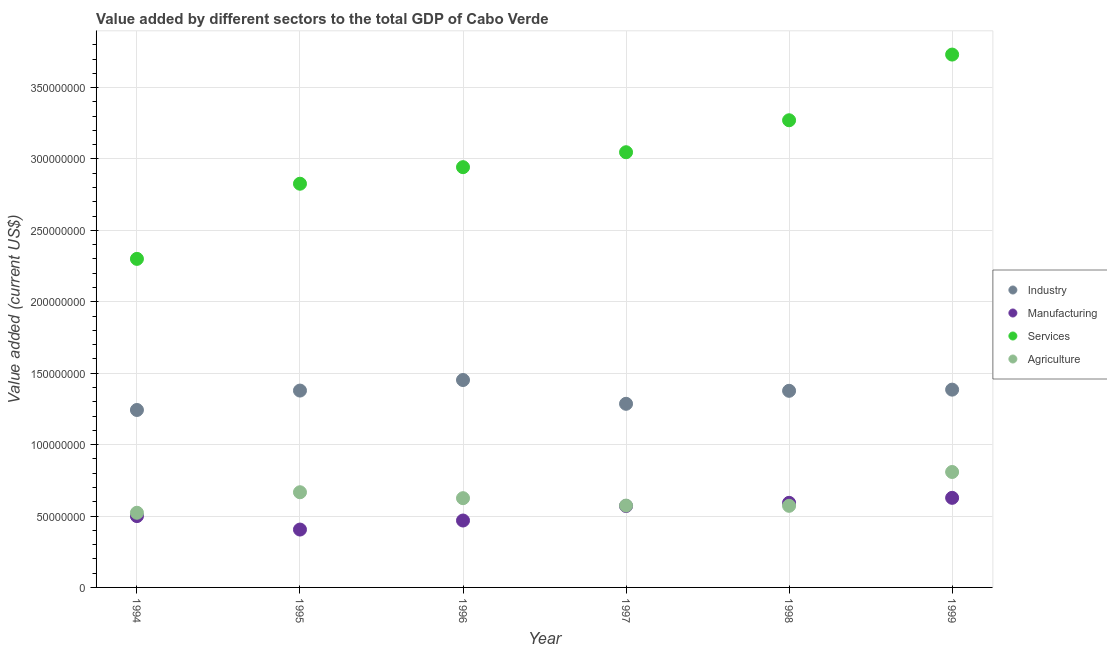Is the number of dotlines equal to the number of legend labels?
Keep it short and to the point. Yes. What is the value added by services sector in 1999?
Provide a succinct answer. 3.73e+08. Across all years, what is the maximum value added by manufacturing sector?
Your response must be concise. 6.27e+07. Across all years, what is the minimum value added by industrial sector?
Your answer should be compact. 1.24e+08. In which year was the value added by agricultural sector minimum?
Provide a short and direct response. 1994. What is the total value added by agricultural sector in the graph?
Your response must be concise. 3.77e+08. What is the difference between the value added by manufacturing sector in 1996 and that in 1998?
Your answer should be compact. -1.24e+07. What is the difference between the value added by industrial sector in 1998 and the value added by services sector in 1996?
Ensure brevity in your answer.  -1.57e+08. What is the average value added by industrial sector per year?
Keep it short and to the point. 1.35e+08. In the year 1998, what is the difference between the value added by services sector and value added by industrial sector?
Offer a terse response. 1.89e+08. What is the ratio of the value added by industrial sector in 1997 to that in 1998?
Your response must be concise. 0.93. Is the value added by agricultural sector in 1997 less than that in 1998?
Your answer should be very brief. No. What is the difference between the highest and the second highest value added by agricultural sector?
Offer a very short reply. 1.42e+07. What is the difference between the highest and the lowest value added by industrial sector?
Offer a terse response. 2.10e+07. In how many years, is the value added by manufacturing sector greater than the average value added by manufacturing sector taken over all years?
Provide a short and direct response. 3. Is the sum of the value added by agricultural sector in 1996 and 1997 greater than the maximum value added by industrial sector across all years?
Make the answer very short. No. Is it the case that in every year, the sum of the value added by industrial sector and value added by manufacturing sector is greater than the value added by services sector?
Keep it short and to the point. No. Does the value added by services sector monotonically increase over the years?
Make the answer very short. Yes. Is the value added by manufacturing sector strictly less than the value added by industrial sector over the years?
Your answer should be very brief. Yes. What is the difference between two consecutive major ticks on the Y-axis?
Offer a terse response. 5.00e+07. Does the graph contain any zero values?
Keep it short and to the point. No. Does the graph contain grids?
Offer a very short reply. Yes. What is the title of the graph?
Provide a short and direct response. Value added by different sectors to the total GDP of Cabo Verde. What is the label or title of the Y-axis?
Make the answer very short. Value added (current US$). What is the Value added (current US$) of Industry in 1994?
Your answer should be very brief. 1.24e+08. What is the Value added (current US$) in Manufacturing in 1994?
Ensure brevity in your answer.  4.99e+07. What is the Value added (current US$) in Services in 1994?
Your response must be concise. 2.30e+08. What is the Value added (current US$) of Agriculture in 1994?
Give a very brief answer. 5.23e+07. What is the Value added (current US$) of Industry in 1995?
Your response must be concise. 1.38e+08. What is the Value added (current US$) in Manufacturing in 1995?
Provide a short and direct response. 4.05e+07. What is the Value added (current US$) in Services in 1995?
Your answer should be very brief. 2.83e+08. What is the Value added (current US$) in Agriculture in 1995?
Offer a terse response. 6.66e+07. What is the Value added (current US$) of Industry in 1996?
Your answer should be very brief. 1.45e+08. What is the Value added (current US$) of Manufacturing in 1996?
Offer a very short reply. 4.68e+07. What is the Value added (current US$) in Services in 1996?
Provide a succinct answer. 2.94e+08. What is the Value added (current US$) in Agriculture in 1996?
Keep it short and to the point. 6.25e+07. What is the Value added (current US$) of Industry in 1997?
Your response must be concise. 1.29e+08. What is the Value added (current US$) of Manufacturing in 1997?
Give a very brief answer. 5.70e+07. What is the Value added (current US$) of Services in 1997?
Keep it short and to the point. 3.05e+08. What is the Value added (current US$) in Agriculture in 1997?
Give a very brief answer. 5.73e+07. What is the Value added (current US$) in Industry in 1998?
Give a very brief answer. 1.38e+08. What is the Value added (current US$) of Manufacturing in 1998?
Give a very brief answer. 5.92e+07. What is the Value added (current US$) in Services in 1998?
Provide a short and direct response. 3.27e+08. What is the Value added (current US$) in Agriculture in 1998?
Your answer should be compact. 5.71e+07. What is the Value added (current US$) of Industry in 1999?
Your answer should be compact. 1.38e+08. What is the Value added (current US$) of Manufacturing in 1999?
Your answer should be very brief. 6.27e+07. What is the Value added (current US$) in Services in 1999?
Your answer should be compact. 3.73e+08. What is the Value added (current US$) in Agriculture in 1999?
Make the answer very short. 8.08e+07. Across all years, what is the maximum Value added (current US$) of Industry?
Make the answer very short. 1.45e+08. Across all years, what is the maximum Value added (current US$) of Manufacturing?
Your response must be concise. 6.27e+07. Across all years, what is the maximum Value added (current US$) in Services?
Give a very brief answer. 3.73e+08. Across all years, what is the maximum Value added (current US$) in Agriculture?
Your response must be concise. 8.08e+07. Across all years, what is the minimum Value added (current US$) in Industry?
Your answer should be very brief. 1.24e+08. Across all years, what is the minimum Value added (current US$) of Manufacturing?
Ensure brevity in your answer.  4.05e+07. Across all years, what is the minimum Value added (current US$) in Services?
Offer a very short reply. 2.30e+08. Across all years, what is the minimum Value added (current US$) in Agriculture?
Keep it short and to the point. 5.23e+07. What is the total Value added (current US$) of Industry in the graph?
Offer a terse response. 8.12e+08. What is the total Value added (current US$) in Manufacturing in the graph?
Give a very brief answer. 3.16e+08. What is the total Value added (current US$) of Services in the graph?
Your answer should be very brief. 1.81e+09. What is the total Value added (current US$) in Agriculture in the graph?
Offer a very short reply. 3.77e+08. What is the difference between the Value added (current US$) of Industry in 1994 and that in 1995?
Provide a short and direct response. -1.36e+07. What is the difference between the Value added (current US$) of Manufacturing in 1994 and that in 1995?
Provide a succinct answer. 9.43e+06. What is the difference between the Value added (current US$) of Services in 1994 and that in 1995?
Ensure brevity in your answer.  -5.26e+07. What is the difference between the Value added (current US$) in Agriculture in 1994 and that in 1995?
Offer a terse response. -1.44e+07. What is the difference between the Value added (current US$) in Industry in 1994 and that in 1996?
Provide a succinct answer. -2.10e+07. What is the difference between the Value added (current US$) in Manufacturing in 1994 and that in 1996?
Your response must be concise. 3.10e+06. What is the difference between the Value added (current US$) of Services in 1994 and that in 1996?
Offer a very short reply. -6.42e+07. What is the difference between the Value added (current US$) in Agriculture in 1994 and that in 1996?
Keep it short and to the point. -1.02e+07. What is the difference between the Value added (current US$) of Industry in 1994 and that in 1997?
Keep it short and to the point. -4.33e+06. What is the difference between the Value added (current US$) of Manufacturing in 1994 and that in 1997?
Your answer should be compact. -7.07e+06. What is the difference between the Value added (current US$) of Services in 1994 and that in 1997?
Provide a succinct answer. -7.47e+07. What is the difference between the Value added (current US$) of Agriculture in 1994 and that in 1997?
Provide a short and direct response. -5.02e+06. What is the difference between the Value added (current US$) of Industry in 1994 and that in 1998?
Ensure brevity in your answer.  -1.34e+07. What is the difference between the Value added (current US$) of Manufacturing in 1994 and that in 1998?
Provide a succinct answer. -9.28e+06. What is the difference between the Value added (current US$) in Services in 1994 and that in 1998?
Keep it short and to the point. -9.71e+07. What is the difference between the Value added (current US$) in Agriculture in 1994 and that in 1998?
Give a very brief answer. -4.85e+06. What is the difference between the Value added (current US$) of Industry in 1994 and that in 1999?
Offer a terse response. -1.42e+07. What is the difference between the Value added (current US$) of Manufacturing in 1994 and that in 1999?
Provide a short and direct response. -1.28e+07. What is the difference between the Value added (current US$) in Services in 1994 and that in 1999?
Give a very brief answer. -1.43e+08. What is the difference between the Value added (current US$) of Agriculture in 1994 and that in 1999?
Provide a succinct answer. -2.85e+07. What is the difference between the Value added (current US$) in Industry in 1995 and that in 1996?
Offer a terse response. -7.39e+06. What is the difference between the Value added (current US$) of Manufacturing in 1995 and that in 1996?
Provide a succinct answer. -6.33e+06. What is the difference between the Value added (current US$) of Services in 1995 and that in 1996?
Your answer should be compact. -1.16e+07. What is the difference between the Value added (current US$) of Agriculture in 1995 and that in 1996?
Give a very brief answer. 4.16e+06. What is the difference between the Value added (current US$) of Industry in 1995 and that in 1997?
Provide a succinct answer. 9.26e+06. What is the difference between the Value added (current US$) in Manufacturing in 1995 and that in 1997?
Offer a terse response. -1.65e+07. What is the difference between the Value added (current US$) in Services in 1995 and that in 1997?
Keep it short and to the point. -2.21e+07. What is the difference between the Value added (current US$) of Agriculture in 1995 and that in 1997?
Keep it short and to the point. 9.34e+06. What is the difference between the Value added (current US$) of Industry in 1995 and that in 1998?
Offer a very short reply. 1.66e+05. What is the difference between the Value added (current US$) of Manufacturing in 1995 and that in 1998?
Provide a succinct answer. -1.87e+07. What is the difference between the Value added (current US$) in Services in 1995 and that in 1998?
Your answer should be very brief. -4.44e+07. What is the difference between the Value added (current US$) of Agriculture in 1995 and that in 1998?
Offer a very short reply. 9.51e+06. What is the difference between the Value added (current US$) of Industry in 1995 and that in 1999?
Keep it short and to the point. -6.55e+05. What is the difference between the Value added (current US$) of Manufacturing in 1995 and that in 1999?
Provide a succinct answer. -2.22e+07. What is the difference between the Value added (current US$) of Services in 1995 and that in 1999?
Your answer should be compact. -9.04e+07. What is the difference between the Value added (current US$) in Agriculture in 1995 and that in 1999?
Your response must be concise. -1.42e+07. What is the difference between the Value added (current US$) of Industry in 1996 and that in 1997?
Make the answer very short. 1.67e+07. What is the difference between the Value added (current US$) in Manufacturing in 1996 and that in 1997?
Keep it short and to the point. -1.02e+07. What is the difference between the Value added (current US$) in Services in 1996 and that in 1997?
Make the answer very short. -1.05e+07. What is the difference between the Value added (current US$) of Agriculture in 1996 and that in 1997?
Provide a short and direct response. 5.18e+06. What is the difference between the Value added (current US$) in Industry in 1996 and that in 1998?
Ensure brevity in your answer.  7.56e+06. What is the difference between the Value added (current US$) of Manufacturing in 1996 and that in 1998?
Ensure brevity in your answer.  -1.24e+07. What is the difference between the Value added (current US$) of Services in 1996 and that in 1998?
Offer a terse response. -3.28e+07. What is the difference between the Value added (current US$) of Agriculture in 1996 and that in 1998?
Offer a terse response. 5.35e+06. What is the difference between the Value added (current US$) in Industry in 1996 and that in 1999?
Your response must be concise. 6.74e+06. What is the difference between the Value added (current US$) in Manufacturing in 1996 and that in 1999?
Your answer should be very brief. -1.59e+07. What is the difference between the Value added (current US$) of Services in 1996 and that in 1999?
Your answer should be compact. -7.88e+07. What is the difference between the Value added (current US$) in Agriculture in 1996 and that in 1999?
Offer a very short reply. -1.83e+07. What is the difference between the Value added (current US$) of Industry in 1997 and that in 1998?
Offer a very short reply. -9.09e+06. What is the difference between the Value added (current US$) in Manufacturing in 1997 and that in 1998?
Give a very brief answer. -2.22e+06. What is the difference between the Value added (current US$) in Services in 1997 and that in 1998?
Ensure brevity in your answer.  -2.24e+07. What is the difference between the Value added (current US$) of Agriculture in 1997 and that in 1998?
Your answer should be very brief. 1.71e+05. What is the difference between the Value added (current US$) in Industry in 1997 and that in 1999?
Your answer should be very brief. -9.91e+06. What is the difference between the Value added (current US$) of Manufacturing in 1997 and that in 1999?
Keep it short and to the point. -5.71e+06. What is the difference between the Value added (current US$) in Services in 1997 and that in 1999?
Make the answer very short. -6.84e+07. What is the difference between the Value added (current US$) of Agriculture in 1997 and that in 1999?
Your answer should be very brief. -2.35e+07. What is the difference between the Value added (current US$) of Industry in 1998 and that in 1999?
Provide a succinct answer. -8.20e+05. What is the difference between the Value added (current US$) in Manufacturing in 1998 and that in 1999?
Offer a very short reply. -3.49e+06. What is the difference between the Value added (current US$) of Services in 1998 and that in 1999?
Provide a succinct answer. -4.60e+07. What is the difference between the Value added (current US$) in Agriculture in 1998 and that in 1999?
Make the answer very short. -2.37e+07. What is the difference between the Value added (current US$) of Industry in 1994 and the Value added (current US$) of Manufacturing in 1995?
Make the answer very short. 8.37e+07. What is the difference between the Value added (current US$) of Industry in 1994 and the Value added (current US$) of Services in 1995?
Ensure brevity in your answer.  -1.58e+08. What is the difference between the Value added (current US$) of Industry in 1994 and the Value added (current US$) of Agriculture in 1995?
Ensure brevity in your answer.  5.76e+07. What is the difference between the Value added (current US$) in Manufacturing in 1994 and the Value added (current US$) in Services in 1995?
Your answer should be very brief. -2.33e+08. What is the difference between the Value added (current US$) of Manufacturing in 1994 and the Value added (current US$) of Agriculture in 1995?
Make the answer very short. -1.67e+07. What is the difference between the Value added (current US$) of Services in 1994 and the Value added (current US$) of Agriculture in 1995?
Ensure brevity in your answer.  1.63e+08. What is the difference between the Value added (current US$) in Industry in 1994 and the Value added (current US$) in Manufacturing in 1996?
Your answer should be very brief. 7.74e+07. What is the difference between the Value added (current US$) in Industry in 1994 and the Value added (current US$) in Services in 1996?
Make the answer very short. -1.70e+08. What is the difference between the Value added (current US$) of Industry in 1994 and the Value added (current US$) of Agriculture in 1996?
Provide a short and direct response. 6.18e+07. What is the difference between the Value added (current US$) in Manufacturing in 1994 and the Value added (current US$) in Services in 1996?
Provide a short and direct response. -2.44e+08. What is the difference between the Value added (current US$) of Manufacturing in 1994 and the Value added (current US$) of Agriculture in 1996?
Your answer should be compact. -1.25e+07. What is the difference between the Value added (current US$) of Services in 1994 and the Value added (current US$) of Agriculture in 1996?
Offer a very short reply. 1.68e+08. What is the difference between the Value added (current US$) of Industry in 1994 and the Value added (current US$) of Manufacturing in 1997?
Provide a short and direct response. 6.72e+07. What is the difference between the Value added (current US$) of Industry in 1994 and the Value added (current US$) of Services in 1997?
Ensure brevity in your answer.  -1.80e+08. What is the difference between the Value added (current US$) of Industry in 1994 and the Value added (current US$) of Agriculture in 1997?
Provide a succinct answer. 6.69e+07. What is the difference between the Value added (current US$) in Manufacturing in 1994 and the Value added (current US$) in Services in 1997?
Offer a very short reply. -2.55e+08. What is the difference between the Value added (current US$) in Manufacturing in 1994 and the Value added (current US$) in Agriculture in 1997?
Offer a terse response. -7.36e+06. What is the difference between the Value added (current US$) in Services in 1994 and the Value added (current US$) in Agriculture in 1997?
Provide a succinct answer. 1.73e+08. What is the difference between the Value added (current US$) of Industry in 1994 and the Value added (current US$) of Manufacturing in 1998?
Keep it short and to the point. 6.50e+07. What is the difference between the Value added (current US$) in Industry in 1994 and the Value added (current US$) in Services in 1998?
Ensure brevity in your answer.  -2.03e+08. What is the difference between the Value added (current US$) of Industry in 1994 and the Value added (current US$) of Agriculture in 1998?
Keep it short and to the point. 6.71e+07. What is the difference between the Value added (current US$) of Manufacturing in 1994 and the Value added (current US$) of Services in 1998?
Ensure brevity in your answer.  -2.77e+08. What is the difference between the Value added (current US$) of Manufacturing in 1994 and the Value added (current US$) of Agriculture in 1998?
Provide a succinct answer. -7.19e+06. What is the difference between the Value added (current US$) in Services in 1994 and the Value added (current US$) in Agriculture in 1998?
Offer a very short reply. 1.73e+08. What is the difference between the Value added (current US$) in Industry in 1994 and the Value added (current US$) in Manufacturing in 1999?
Offer a terse response. 6.15e+07. What is the difference between the Value added (current US$) in Industry in 1994 and the Value added (current US$) in Services in 1999?
Keep it short and to the point. -2.49e+08. What is the difference between the Value added (current US$) in Industry in 1994 and the Value added (current US$) in Agriculture in 1999?
Your answer should be very brief. 4.34e+07. What is the difference between the Value added (current US$) in Manufacturing in 1994 and the Value added (current US$) in Services in 1999?
Ensure brevity in your answer.  -3.23e+08. What is the difference between the Value added (current US$) in Manufacturing in 1994 and the Value added (current US$) in Agriculture in 1999?
Your answer should be compact. -3.09e+07. What is the difference between the Value added (current US$) in Services in 1994 and the Value added (current US$) in Agriculture in 1999?
Provide a succinct answer. 1.49e+08. What is the difference between the Value added (current US$) of Industry in 1995 and the Value added (current US$) of Manufacturing in 1996?
Offer a terse response. 9.10e+07. What is the difference between the Value added (current US$) in Industry in 1995 and the Value added (current US$) in Services in 1996?
Your answer should be compact. -1.56e+08. What is the difference between the Value added (current US$) in Industry in 1995 and the Value added (current US$) in Agriculture in 1996?
Your response must be concise. 7.53e+07. What is the difference between the Value added (current US$) of Manufacturing in 1995 and the Value added (current US$) of Services in 1996?
Offer a very short reply. -2.54e+08. What is the difference between the Value added (current US$) in Manufacturing in 1995 and the Value added (current US$) in Agriculture in 1996?
Offer a terse response. -2.20e+07. What is the difference between the Value added (current US$) in Services in 1995 and the Value added (current US$) in Agriculture in 1996?
Your response must be concise. 2.20e+08. What is the difference between the Value added (current US$) of Industry in 1995 and the Value added (current US$) of Manufacturing in 1997?
Your answer should be compact. 8.08e+07. What is the difference between the Value added (current US$) of Industry in 1995 and the Value added (current US$) of Services in 1997?
Give a very brief answer. -1.67e+08. What is the difference between the Value added (current US$) in Industry in 1995 and the Value added (current US$) in Agriculture in 1997?
Give a very brief answer. 8.05e+07. What is the difference between the Value added (current US$) in Manufacturing in 1995 and the Value added (current US$) in Services in 1997?
Offer a very short reply. -2.64e+08. What is the difference between the Value added (current US$) in Manufacturing in 1995 and the Value added (current US$) in Agriculture in 1997?
Provide a short and direct response. -1.68e+07. What is the difference between the Value added (current US$) in Services in 1995 and the Value added (current US$) in Agriculture in 1997?
Provide a succinct answer. 2.25e+08. What is the difference between the Value added (current US$) in Industry in 1995 and the Value added (current US$) in Manufacturing in 1998?
Offer a terse response. 7.86e+07. What is the difference between the Value added (current US$) in Industry in 1995 and the Value added (current US$) in Services in 1998?
Offer a very short reply. -1.89e+08. What is the difference between the Value added (current US$) in Industry in 1995 and the Value added (current US$) in Agriculture in 1998?
Ensure brevity in your answer.  8.07e+07. What is the difference between the Value added (current US$) of Manufacturing in 1995 and the Value added (current US$) of Services in 1998?
Make the answer very short. -2.87e+08. What is the difference between the Value added (current US$) of Manufacturing in 1995 and the Value added (current US$) of Agriculture in 1998?
Keep it short and to the point. -1.66e+07. What is the difference between the Value added (current US$) in Services in 1995 and the Value added (current US$) in Agriculture in 1998?
Your response must be concise. 2.26e+08. What is the difference between the Value added (current US$) of Industry in 1995 and the Value added (current US$) of Manufacturing in 1999?
Provide a succinct answer. 7.51e+07. What is the difference between the Value added (current US$) in Industry in 1995 and the Value added (current US$) in Services in 1999?
Provide a short and direct response. -2.35e+08. What is the difference between the Value added (current US$) in Industry in 1995 and the Value added (current US$) in Agriculture in 1999?
Make the answer very short. 5.70e+07. What is the difference between the Value added (current US$) in Manufacturing in 1995 and the Value added (current US$) in Services in 1999?
Provide a short and direct response. -3.33e+08. What is the difference between the Value added (current US$) of Manufacturing in 1995 and the Value added (current US$) of Agriculture in 1999?
Provide a succinct answer. -4.03e+07. What is the difference between the Value added (current US$) in Services in 1995 and the Value added (current US$) in Agriculture in 1999?
Provide a succinct answer. 2.02e+08. What is the difference between the Value added (current US$) in Industry in 1996 and the Value added (current US$) in Manufacturing in 1997?
Give a very brief answer. 8.82e+07. What is the difference between the Value added (current US$) of Industry in 1996 and the Value added (current US$) of Services in 1997?
Your answer should be very brief. -1.60e+08. What is the difference between the Value added (current US$) in Industry in 1996 and the Value added (current US$) in Agriculture in 1997?
Provide a short and direct response. 8.79e+07. What is the difference between the Value added (current US$) of Manufacturing in 1996 and the Value added (current US$) of Services in 1997?
Your answer should be compact. -2.58e+08. What is the difference between the Value added (current US$) of Manufacturing in 1996 and the Value added (current US$) of Agriculture in 1997?
Provide a succinct answer. -1.05e+07. What is the difference between the Value added (current US$) in Services in 1996 and the Value added (current US$) in Agriculture in 1997?
Your response must be concise. 2.37e+08. What is the difference between the Value added (current US$) of Industry in 1996 and the Value added (current US$) of Manufacturing in 1998?
Provide a short and direct response. 8.60e+07. What is the difference between the Value added (current US$) in Industry in 1996 and the Value added (current US$) in Services in 1998?
Make the answer very short. -1.82e+08. What is the difference between the Value added (current US$) of Industry in 1996 and the Value added (current US$) of Agriculture in 1998?
Give a very brief answer. 8.81e+07. What is the difference between the Value added (current US$) in Manufacturing in 1996 and the Value added (current US$) in Services in 1998?
Your response must be concise. -2.80e+08. What is the difference between the Value added (current US$) of Manufacturing in 1996 and the Value added (current US$) of Agriculture in 1998?
Keep it short and to the point. -1.03e+07. What is the difference between the Value added (current US$) of Services in 1996 and the Value added (current US$) of Agriculture in 1998?
Keep it short and to the point. 2.37e+08. What is the difference between the Value added (current US$) of Industry in 1996 and the Value added (current US$) of Manufacturing in 1999?
Offer a very short reply. 8.25e+07. What is the difference between the Value added (current US$) of Industry in 1996 and the Value added (current US$) of Services in 1999?
Your answer should be compact. -2.28e+08. What is the difference between the Value added (current US$) in Industry in 1996 and the Value added (current US$) in Agriculture in 1999?
Offer a very short reply. 6.44e+07. What is the difference between the Value added (current US$) of Manufacturing in 1996 and the Value added (current US$) of Services in 1999?
Your response must be concise. -3.26e+08. What is the difference between the Value added (current US$) in Manufacturing in 1996 and the Value added (current US$) in Agriculture in 1999?
Provide a succinct answer. -3.40e+07. What is the difference between the Value added (current US$) in Services in 1996 and the Value added (current US$) in Agriculture in 1999?
Offer a terse response. 2.13e+08. What is the difference between the Value added (current US$) in Industry in 1997 and the Value added (current US$) in Manufacturing in 1998?
Ensure brevity in your answer.  6.93e+07. What is the difference between the Value added (current US$) in Industry in 1997 and the Value added (current US$) in Services in 1998?
Make the answer very short. -1.99e+08. What is the difference between the Value added (current US$) in Industry in 1997 and the Value added (current US$) in Agriculture in 1998?
Your response must be concise. 7.14e+07. What is the difference between the Value added (current US$) of Manufacturing in 1997 and the Value added (current US$) of Services in 1998?
Provide a succinct answer. -2.70e+08. What is the difference between the Value added (current US$) of Manufacturing in 1997 and the Value added (current US$) of Agriculture in 1998?
Give a very brief answer. -1.19e+05. What is the difference between the Value added (current US$) of Services in 1997 and the Value added (current US$) of Agriculture in 1998?
Your answer should be compact. 2.48e+08. What is the difference between the Value added (current US$) of Industry in 1997 and the Value added (current US$) of Manufacturing in 1999?
Give a very brief answer. 6.58e+07. What is the difference between the Value added (current US$) of Industry in 1997 and the Value added (current US$) of Services in 1999?
Provide a succinct answer. -2.45e+08. What is the difference between the Value added (current US$) in Industry in 1997 and the Value added (current US$) in Agriculture in 1999?
Offer a very short reply. 4.77e+07. What is the difference between the Value added (current US$) of Manufacturing in 1997 and the Value added (current US$) of Services in 1999?
Your answer should be very brief. -3.16e+08. What is the difference between the Value added (current US$) of Manufacturing in 1997 and the Value added (current US$) of Agriculture in 1999?
Your response must be concise. -2.38e+07. What is the difference between the Value added (current US$) in Services in 1997 and the Value added (current US$) in Agriculture in 1999?
Make the answer very short. 2.24e+08. What is the difference between the Value added (current US$) in Industry in 1998 and the Value added (current US$) in Manufacturing in 1999?
Your response must be concise. 7.49e+07. What is the difference between the Value added (current US$) of Industry in 1998 and the Value added (current US$) of Services in 1999?
Offer a very short reply. -2.35e+08. What is the difference between the Value added (current US$) of Industry in 1998 and the Value added (current US$) of Agriculture in 1999?
Ensure brevity in your answer.  5.68e+07. What is the difference between the Value added (current US$) of Manufacturing in 1998 and the Value added (current US$) of Services in 1999?
Make the answer very short. -3.14e+08. What is the difference between the Value added (current US$) in Manufacturing in 1998 and the Value added (current US$) in Agriculture in 1999?
Ensure brevity in your answer.  -2.16e+07. What is the difference between the Value added (current US$) in Services in 1998 and the Value added (current US$) in Agriculture in 1999?
Provide a short and direct response. 2.46e+08. What is the average Value added (current US$) in Industry per year?
Your response must be concise. 1.35e+08. What is the average Value added (current US$) in Manufacturing per year?
Give a very brief answer. 5.27e+07. What is the average Value added (current US$) of Services per year?
Provide a succinct answer. 3.02e+08. What is the average Value added (current US$) of Agriculture per year?
Make the answer very short. 6.28e+07. In the year 1994, what is the difference between the Value added (current US$) in Industry and Value added (current US$) in Manufacturing?
Keep it short and to the point. 7.43e+07. In the year 1994, what is the difference between the Value added (current US$) in Industry and Value added (current US$) in Services?
Provide a short and direct response. -1.06e+08. In the year 1994, what is the difference between the Value added (current US$) in Industry and Value added (current US$) in Agriculture?
Ensure brevity in your answer.  7.20e+07. In the year 1994, what is the difference between the Value added (current US$) of Manufacturing and Value added (current US$) of Services?
Offer a terse response. -1.80e+08. In the year 1994, what is the difference between the Value added (current US$) of Manufacturing and Value added (current US$) of Agriculture?
Give a very brief answer. -2.33e+06. In the year 1994, what is the difference between the Value added (current US$) of Services and Value added (current US$) of Agriculture?
Provide a succinct answer. 1.78e+08. In the year 1995, what is the difference between the Value added (current US$) of Industry and Value added (current US$) of Manufacturing?
Make the answer very short. 9.73e+07. In the year 1995, what is the difference between the Value added (current US$) in Industry and Value added (current US$) in Services?
Provide a short and direct response. -1.45e+08. In the year 1995, what is the difference between the Value added (current US$) in Industry and Value added (current US$) in Agriculture?
Ensure brevity in your answer.  7.12e+07. In the year 1995, what is the difference between the Value added (current US$) of Manufacturing and Value added (current US$) of Services?
Ensure brevity in your answer.  -2.42e+08. In the year 1995, what is the difference between the Value added (current US$) of Manufacturing and Value added (current US$) of Agriculture?
Your answer should be very brief. -2.61e+07. In the year 1995, what is the difference between the Value added (current US$) in Services and Value added (current US$) in Agriculture?
Your answer should be compact. 2.16e+08. In the year 1996, what is the difference between the Value added (current US$) in Industry and Value added (current US$) in Manufacturing?
Keep it short and to the point. 9.84e+07. In the year 1996, what is the difference between the Value added (current US$) in Industry and Value added (current US$) in Services?
Ensure brevity in your answer.  -1.49e+08. In the year 1996, what is the difference between the Value added (current US$) in Industry and Value added (current US$) in Agriculture?
Your answer should be compact. 8.27e+07. In the year 1996, what is the difference between the Value added (current US$) of Manufacturing and Value added (current US$) of Services?
Provide a succinct answer. -2.47e+08. In the year 1996, what is the difference between the Value added (current US$) of Manufacturing and Value added (current US$) of Agriculture?
Give a very brief answer. -1.56e+07. In the year 1996, what is the difference between the Value added (current US$) in Services and Value added (current US$) in Agriculture?
Offer a very short reply. 2.32e+08. In the year 1997, what is the difference between the Value added (current US$) in Industry and Value added (current US$) in Manufacturing?
Your response must be concise. 7.16e+07. In the year 1997, what is the difference between the Value added (current US$) of Industry and Value added (current US$) of Services?
Provide a succinct answer. -1.76e+08. In the year 1997, what is the difference between the Value added (current US$) in Industry and Value added (current US$) in Agriculture?
Your answer should be very brief. 7.13e+07. In the year 1997, what is the difference between the Value added (current US$) in Manufacturing and Value added (current US$) in Services?
Ensure brevity in your answer.  -2.48e+08. In the year 1997, what is the difference between the Value added (current US$) of Manufacturing and Value added (current US$) of Agriculture?
Keep it short and to the point. -2.91e+05. In the year 1997, what is the difference between the Value added (current US$) of Services and Value added (current US$) of Agriculture?
Offer a terse response. 2.47e+08. In the year 1998, what is the difference between the Value added (current US$) of Industry and Value added (current US$) of Manufacturing?
Make the answer very short. 7.84e+07. In the year 1998, what is the difference between the Value added (current US$) of Industry and Value added (current US$) of Services?
Provide a succinct answer. -1.89e+08. In the year 1998, what is the difference between the Value added (current US$) of Industry and Value added (current US$) of Agriculture?
Offer a very short reply. 8.05e+07. In the year 1998, what is the difference between the Value added (current US$) in Manufacturing and Value added (current US$) in Services?
Give a very brief answer. -2.68e+08. In the year 1998, what is the difference between the Value added (current US$) of Manufacturing and Value added (current US$) of Agriculture?
Your response must be concise. 2.10e+06. In the year 1998, what is the difference between the Value added (current US$) of Services and Value added (current US$) of Agriculture?
Keep it short and to the point. 2.70e+08. In the year 1999, what is the difference between the Value added (current US$) of Industry and Value added (current US$) of Manufacturing?
Offer a terse response. 7.58e+07. In the year 1999, what is the difference between the Value added (current US$) in Industry and Value added (current US$) in Services?
Your response must be concise. -2.35e+08. In the year 1999, what is the difference between the Value added (current US$) of Industry and Value added (current US$) of Agriculture?
Offer a terse response. 5.77e+07. In the year 1999, what is the difference between the Value added (current US$) of Manufacturing and Value added (current US$) of Services?
Your answer should be compact. -3.10e+08. In the year 1999, what is the difference between the Value added (current US$) of Manufacturing and Value added (current US$) of Agriculture?
Provide a short and direct response. -1.81e+07. In the year 1999, what is the difference between the Value added (current US$) of Services and Value added (current US$) of Agriculture?
Provide a succinct answer. 2.92e+08. What is the ratio of the Value added (current US$) of Industry in 1994 to that in 1995?
Keep it short and to the point. 0.9. What is the ratio of the Value added (current US$) in Manufacturing in 1994 to that in 1995?
Offer a very short reply. 1.23. What is the ratio of the Value added (current US$) of Services in 1994 to that in 1995?
Provide a succinct answer. 0.81. What is the ratio of the Value added (current US$) in Agriculture in 1994 to that in 1995?
Provide a succinct answer. 0.78. What is the ratio of the Value added (current US$) in Industry in 1994 to that in 1996?
Your answer should be very brief. 0.86. What is the ratio of the Value added (current US$) in Manufacturing in 1994 to that in 1996?
Provide a succinct answer. 1.07. What is the ratio of the Value added (current US$) in Services in 1994 to that in 1996?
Keep it short and to the point. 0.78. What is the ratio of the Value added (current US$) of Agriculture in 1994 to that in 1996?
Ensure brevity in your answer.  0.84. What is the ratio of the Value added (current US$) in Industry in 1994 to that in 1997?
Offer a terse response. 0.97. What is the ratio of the Value added (current US$) in Manufacturing in 1994 to that in 1997?
Make the answer very short. 0.88. What is the ratio of the Value added (current US$) of Services in 1994 to that in 1997?
Provide a short and direct response. 0.75. What is the ratio of the Value added (current US$) of Agriculture in 1994 to that in 1997?
Your response must be concise. 0.91. What is the ratio of the Value added (current US$) in Industry in 1994 to that in 1998?
Offer a very short reply. 0.9. What is the ratio of the Value added (current US$) in Manufacturing in 1994 to that in 1998?
Offer a terse response. 0.84. What is the ratio of the Value added (current US$) in Services in 1994 to that in 1998?
Provide a short and direct response. 0.7. What is the ratio of the Value added (current US$) in Agriculture in 1994 to that in 1998?
Make the answer very short. 0.92. What is the ratio of the Value added (current US$) in Industry in 1994 to that in 1999?
Your response must be concise. 0.9. What is the ratio of the Value added (current US$) of Manufacturing in 1994 to that in 1999?
Your response must be concise. 0.8. What is the ratio of the Value added (current US$) of Services in 1994 to that in 1999?
Provide a short and direct response. 0.62. What is the ratio of the Value added (current US$) in Agriculture in 1994 to that in 1999?
Your answer should be compact. 0.65. What is the ratio of the Value added (current US$) in Industry in 1995 to that in 1996?
Keep it short and to the point. 0.95. What is the ratio of the Value added (current US$) in Manufacturing in 1995 to that in 1996?
Your answer should be compact. 0.86. What is the ratio of the Value added (current US$) of Services in 1995 to that in 1996?
Offer a very short reply. 0.96. What is the ratio of the Value added (current US$) in Agriculture in 1995 to that in 1996?
Offer a very short reply. 1.07. What is the ratio of the Value added (current US$) in Industry in 1995 to that in 1997?
Make the answer very short. 1.07. What is the ratio of the Value added (current US$) of Manufacturing in 1995 to that in 1997?
Provide a short and direct response. 0.71. What is the ratio of the Value added (current US$) of Services in 1995 to that in 1997?
Offer a very short reply. 0.93. What is the ratio of the Value added (current US$) of Agriculture in 1995 to that in 1997?
Your answer should be compact. 1.16. What is the ratio of the Value added (current US$) of Industry in 1995 to that in 1998?
Ensure brevity in your answer.  1. What is the ratio of the Value added (current US$) of Manufacturing in 1995 to that in 1998?
Give a very brief answer. 0.68. What is the ratio of the Value added (current US$) in Services in 1995 to that in 1998?
Provide a short and direct response. 0.86. What is the ratio of the Value added (current US$) in Agriculture in 1995 to that in 1998?
Provide a succinct answer. 1.17. What is the ratio of the Value added (current US$) in Manufacturing in 1995 to that in 1999?
Provide a short and direct response. 0.65. What is the ratio of the Value added (current US$) of Services in 1995 to that in 1999?
Ensure brevity in your answer.  0.76. What is the ratio of the Value added (current US$) in Agriculture in 1995 to that in 1999?
Ensure brevity in your answer.  0.82. What is the ratio of the Value added (current US$) in Industry in 1996 to that in 1997?
Ensure brevity in your answer.  1.13. What is the ratio of the Value added (current US$) of Manufacturing in 1996 to that in 1997?
Make the answer very short. 0.82. What is the ratio of the Value added (current US$) in Services in 1996 to that in 1997?
Give a very brief answer. 0.97. What is the ratio of the Value added (current US$) in Agriculture in 1996 to that in 1997?
Your answer should be compact. 1.09. What is the ratio of the Value added (current US$) of Industry in 1996 to that in 1998?
Your answer should be very brief. 1.05. What is the ratio of the Value added (current US$) of Manufacturing in 1996 to that in 1998?
Provide a short and direct response. 0.79. What is the ratio of the Value added (current US$) in Services in 1996 to that in 1998?
Keep it short and to the point. 0.9. What is the ratio of the Value added (current US$) in Agriculture in 1996 to that in 1998?
Provide a succinct answer. 1.09. What is the ratio of the Value added (current US$) in Industry in 1996 to that in 1999?
Your answer should be very brief. 1.05. What is the ratio of the Value added (current US$) of Manufacturing in 1996 to that in 1999?
Provide a short and direct response. 0.75. What is the ratio of the Value added (current US$) of Services in 1996 to that in 1999?
Offer a terse response. 0.79. What is the ratio of the Value added (current US$) of Agriculture in 1996 to that in 1999?
Ensure brevity in your answer.  0.77. What is the ratio of the Value added (current US$) of Industry in 1997 to that in 1998?
Keep it short and to the point. 0.93. What is the ratio of the Value added (current US$) in Manufacturing in 1997 to that in 1998?
Offer a very short reply. 0.96. What is the ratio of the Value added (current US$) of Services in 1997 to that in 1998?
Offer a very short reply. 0.93. What is the ratio of the Value added (current US$) of Industry in 1997 to that in 1999?
Provide a short and direct response. 0.93. What is the ratio of the Value added (current US$) in Manufacturing in 1997 to that in 1999?
Make the answer very short. 0.91. What is the ratio of the Value added (current US$) in Services in 1997 to that in 1999?
Offer a terse response. 0.82. What is the ratio of the Value added (current US$) of Agriculture in 1997 to that in 1999?
Make the answer very short. 0.71. What is the ratio of the Value added (current US$) of Manufacturing in 1998 to that in 1999?
Your answer should be very brief. 0.94. What is the ratio of the Value added (current US$) of Services in 1998 to that in 1999?
Offer a very short reply. 0.88. What is the ratio of the Value added (current US$) in Agriculture in 1998 to that in 1999?
Your response must be concise. 0.71. What is the difference between the highest and the second highest Value added (current US$) of Industry?
Your response must be concise. 6.74e+06. What is the difference between the highest and the second highest Value added (current US$) in Manufacturing?
Provide a short and direct response. 3.49e+06. What is the difference between the highest and the second highest Value added (current US$) in Services?
Give a very brief answer. 4.60e+07. What is the difference between the highest and the second highest Value added (current US$) of Agriculture?
Offer a terse response. 1.42e+07. What is the difference between the highest and the lowest Value added (current US$) of Industry?
Your response must be concise. 2.10e+07. What is the difference between the highest and the lowest Value added (current US$) in Manufacturing?
Keep it short and to the point. 2.22e+07. What is the difference between the highest and the lowest Value added (current US$) in Services?
Keep it short and to the point. 1.43e+08. What is the difference between the highest and the lowest Value added (current US$) of Agriculture?
Give a very brief answer. 2.85e+07. 